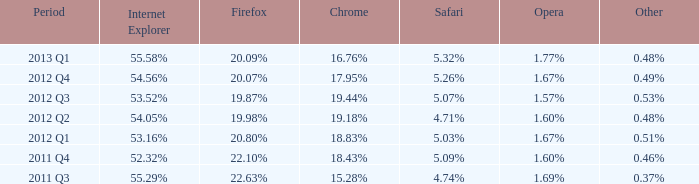52% as the internet explorer? 2012 Q3. 